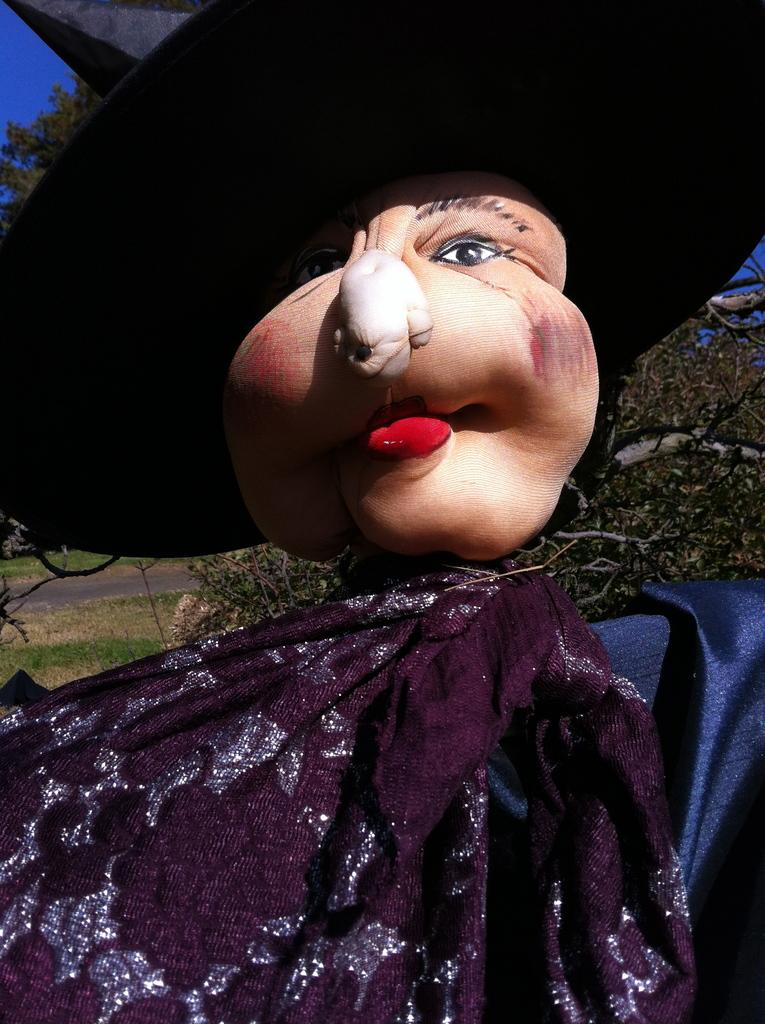What is the main subject of the image? There is a doll in the image. What can be seen on the doll's face? The doll's face is visible in the image. What is the doll wearing on its head? The doll is wearing a black hat. What type of natural environment is visible in the background of the image? There is grass, a tree, and the sky visible in the background of the image. Can you see any ducks swimming in the seashore in the image? There is no seashore or ducks present in the image; it features a doll with a black hat and a natural environment in the background. 